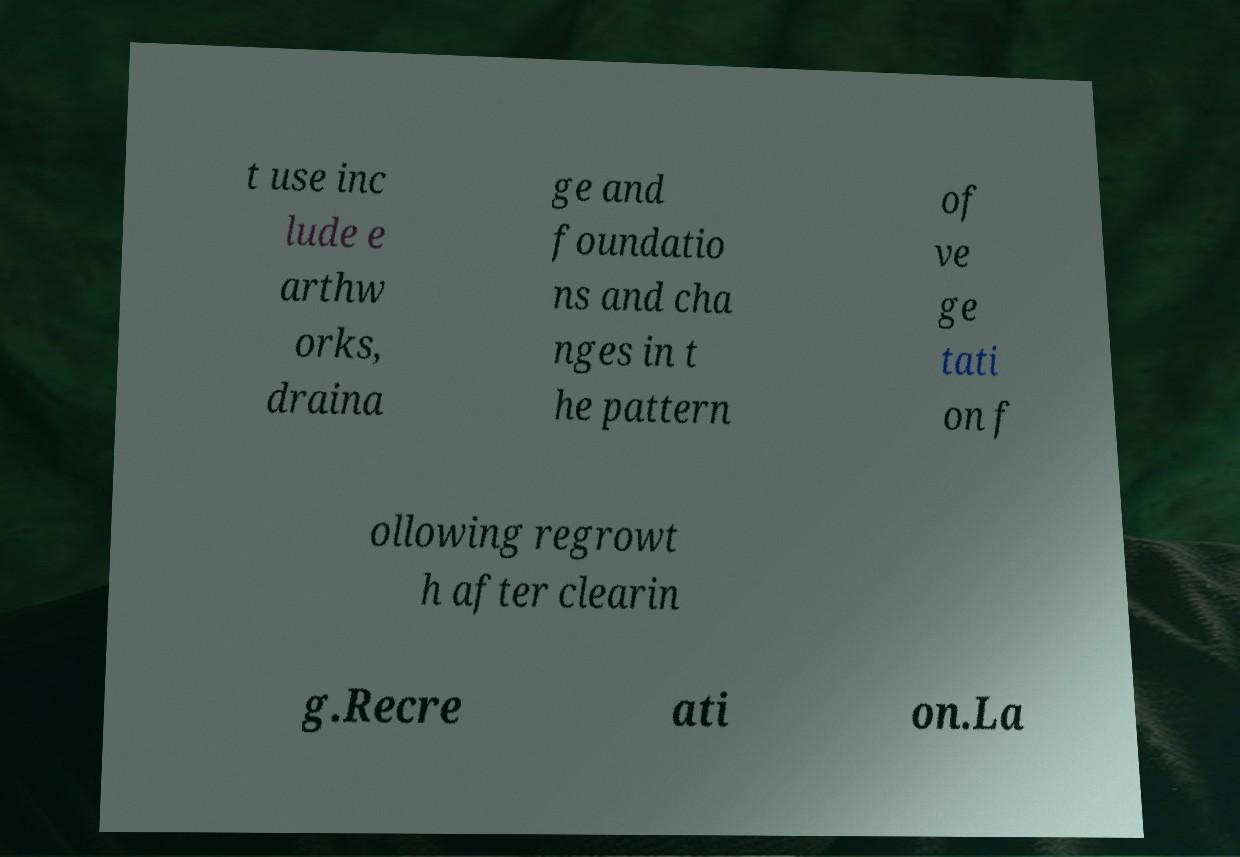Please identify and transcribe the text found in this image. t use inc lude e arthw orks, draina ge and foundatio ns and cha nges in t he pattern of ve ge tati on f ollowing regrowt h after clearin g.Recre ati on.La 